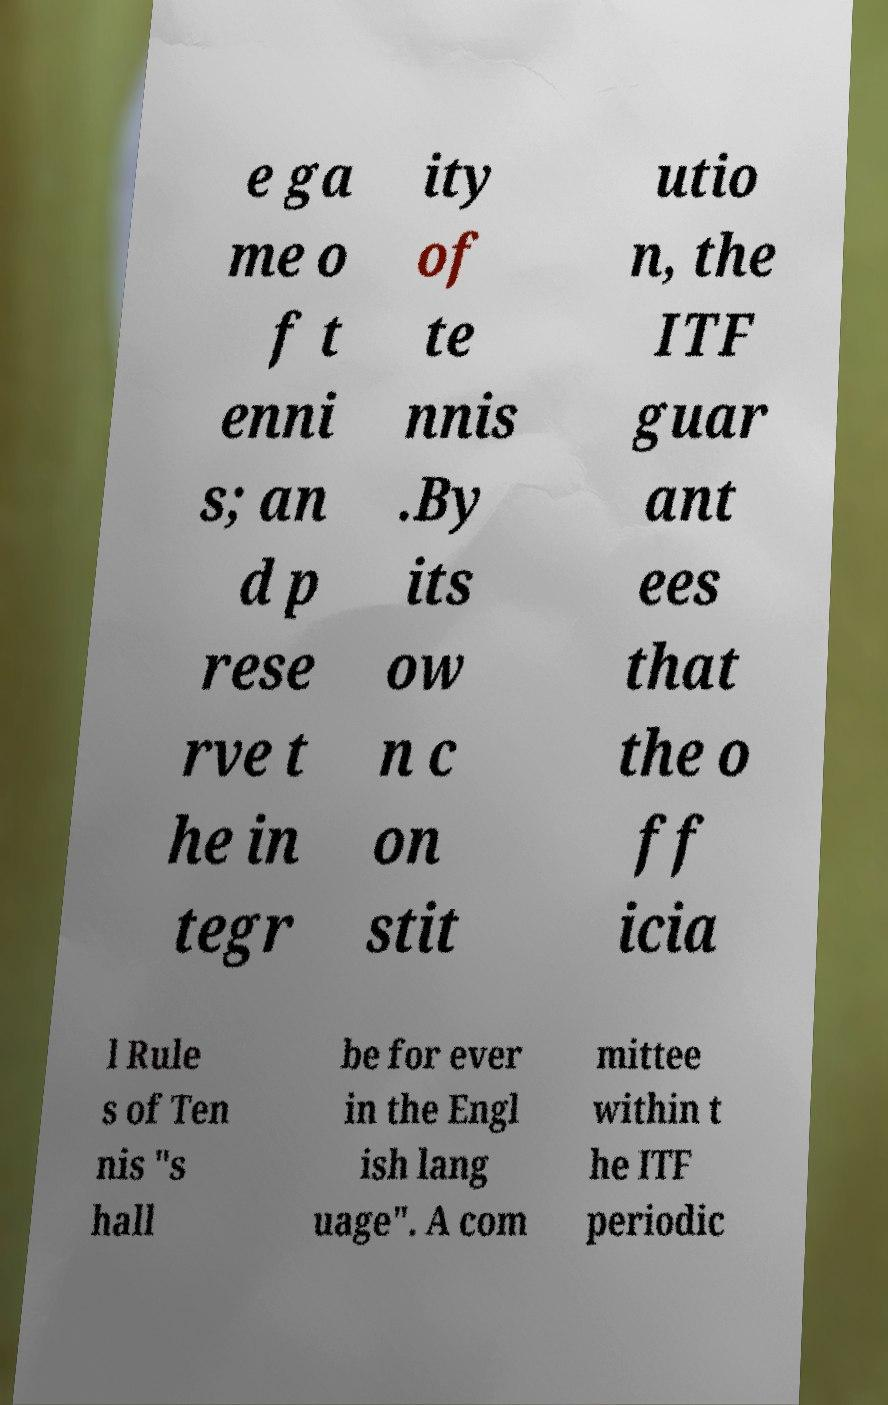Could you assist in decoding the text presented in this image and type it out clearly? e ga me o f t enni s; an d p rese rve t he in tegr ity of te nnis .By its ow n c on stit utio n, the ITF guar ant ees that the o ff icia l Rule s of Ten nis "s hall be for ever in the Engl ish lang uage". A com mittee within t he ITF periodic 